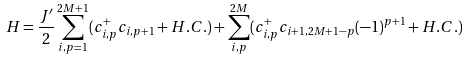<formula> <loc_0><loc_0><loc_500><loc_500>H = \frac { J ^ { \prime } } { 2 } \sum _ { i , p = 1 } ^ { 2 M + 1 } ( c _ { i , p } ^ { + } c _ { i , p + 1 } + H . C . ) + \sum _ { i , p } ^ { 2 M } ( c _ { i , p } ^ { + } c _ { i + 1 , 2 M + 1 - p } ( - 1 ) ^ { p + 1 } + H . C . )</formula> 